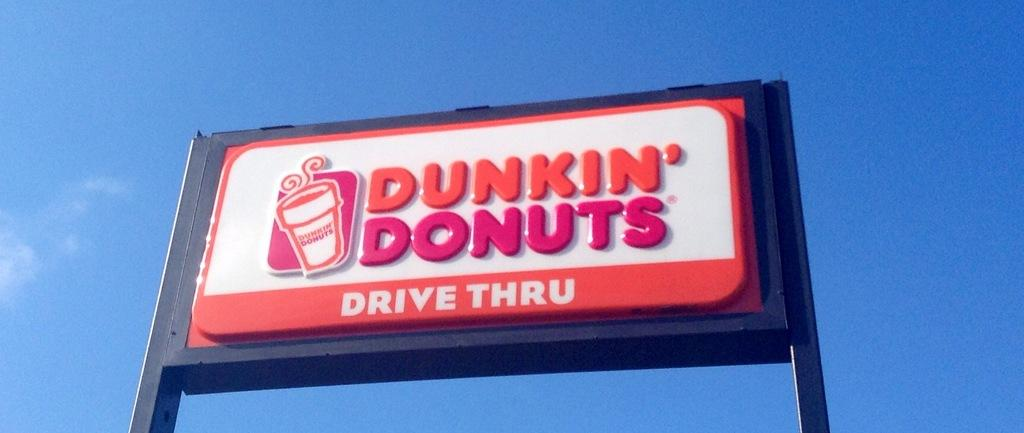<image>
Write a terse but informative summary of the picture. a dunkin donuts sign advertises that they offer a drive through 